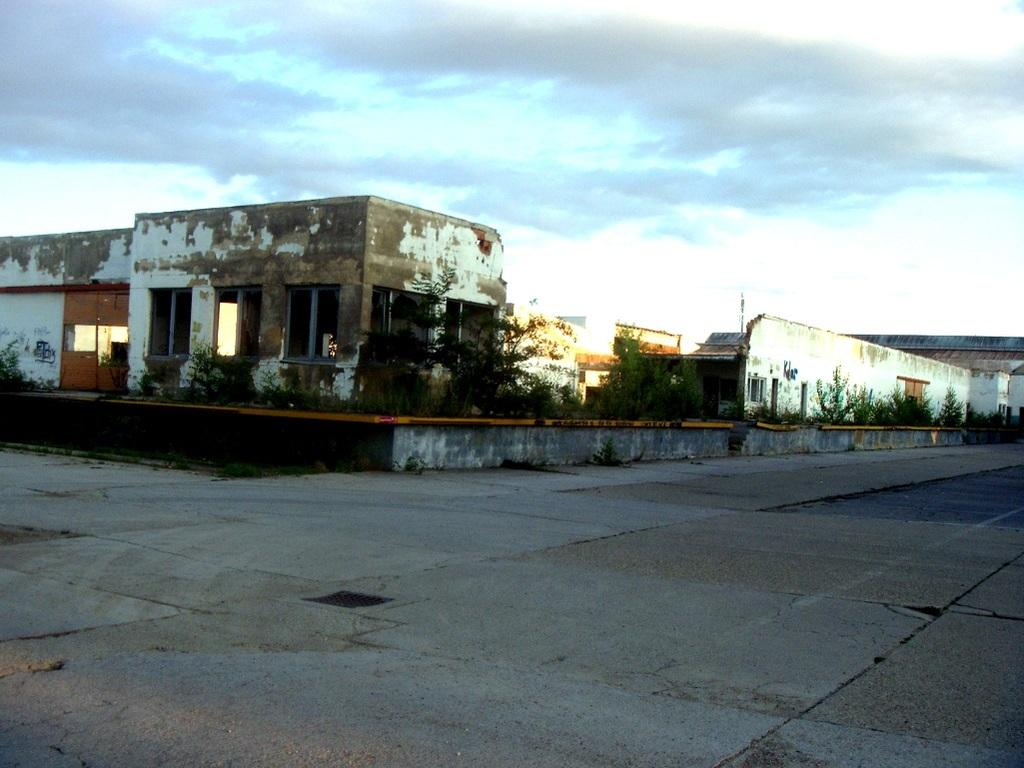What type of structures are present in the image? There are houses in the image. What other elements can be seen in the image besides the houses? There are plants, a wall, and a path visible in the image. What is visible in the background of the image? There is a sky with clouds visible in the background of the image. How many cows are grazing on the scarf in the image? There are no cows or scarves present in the image. 